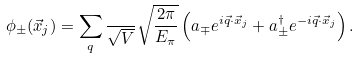<formula> <loc_0><loc_0><loc_500><loc_500>\phi _ { \pm } ( \vec { x } _ { j } ) = \sum _ { q } \frac { } { \sqrt { V } } \sqrt { \frac { 2 \pi } { E _ { \pi } } } \left ( a _ { \mp } e ^ { i \vec { q } \cdot \vec { x } _ { j } } + a _ { \pm } ^ { \dagger } e ^ { - i \vec { q } \cdot \vec { x } _ { j } } \right ) .</formula> 